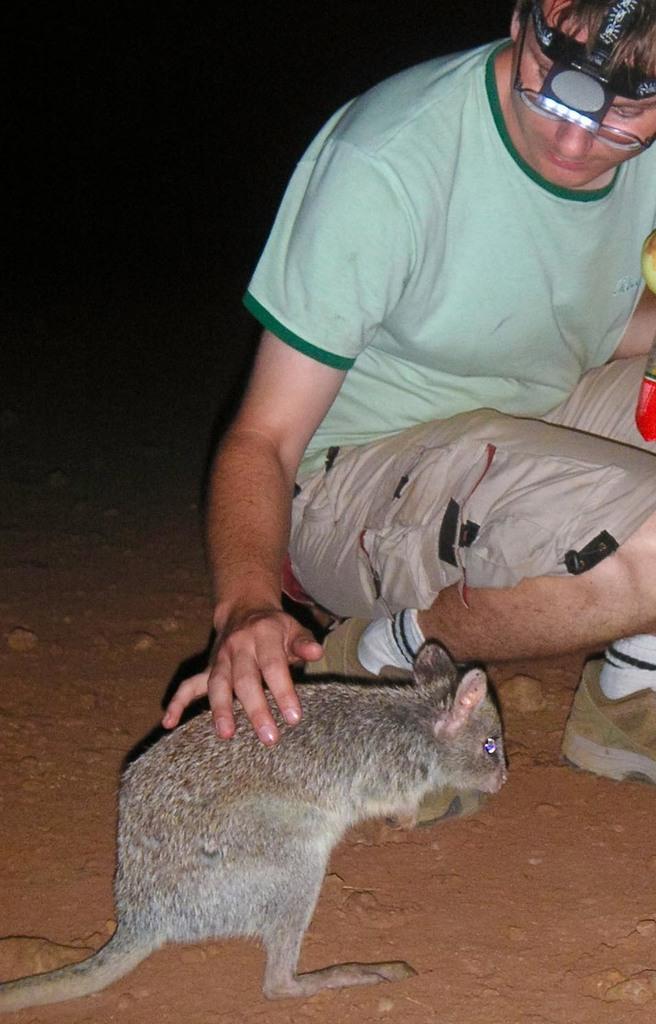How would you summarize this image in a sentence or two? In this picture there is a boy who is sitting on the floor on the right side of the image, by placing his hand on a rat, which is at the bottom side of the image. 